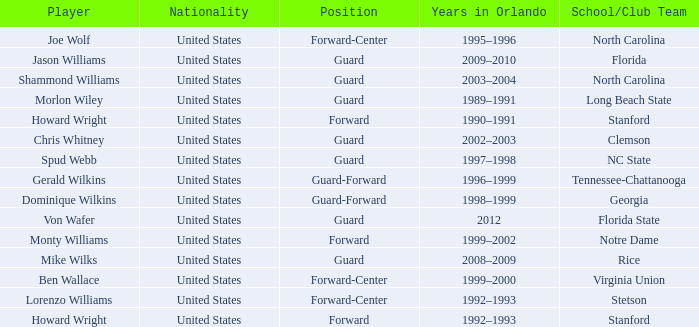What School/Club did Dominique Wilkins play for? Georgia. 